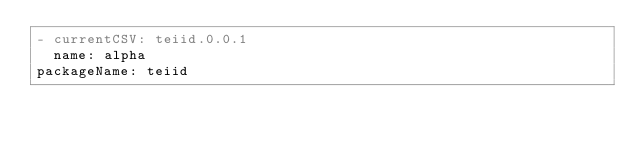Convert code to text. <code><loc_0><loc_0><loc_500><loc_500><_YAML_>- currentCSV: teiid.0.0.1
  name: alpha
packageName: teiid
</code> 